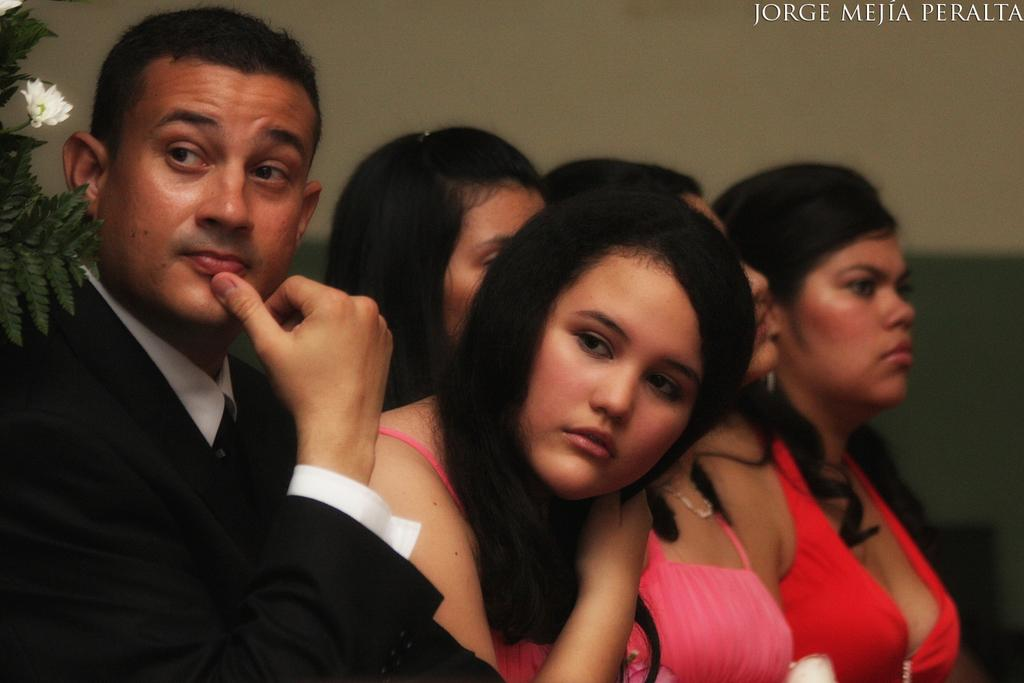What is the main subject of the image? The main subject of the image is a group of people. Where are the people located in the image? The group of people is sitting in the center of the image. What can be seen on the left side of the image? There is a plant on the left side of the image. What type of plate is being used by the group of people in the image? There is no plate visible in the image; the group of people is sitting, not eating. 